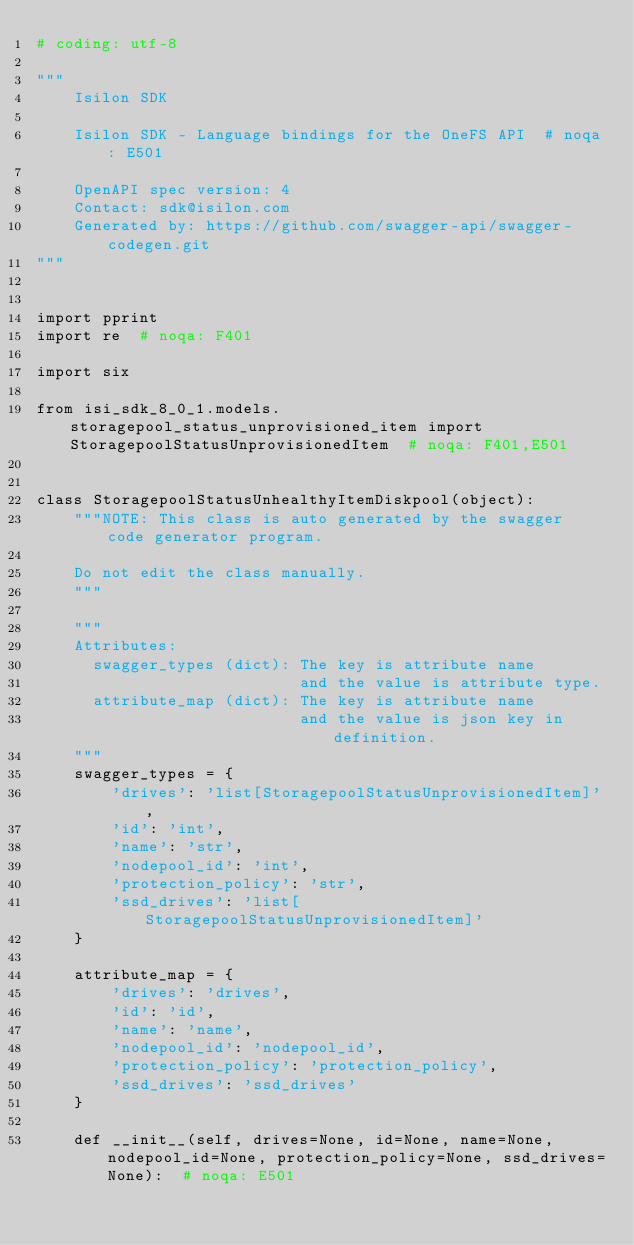Convert code to text. <code><loc_0><loc_0><loc_500><loc_500><_Python_># coding: utf-8

"""
    Isilon SDK

    Isilon SDK - Language bindings for the OneFS API  # noqa: E501

    OpenAPI spec version: 4
    Contact: sdk@isilon.com
    Generated by: https://github.com/swagger-api/swagger-codegen.git
"""


import pprint
import re  # noqa: F401

import six

from isi_sdk_8_0_1.models.storagepool_status_unprovisioned_item import StoragepoolStatusUnprovisionedItem  # noqa: F401,E501


class StoragepoolStatusUnhealthyItemDiskpool(object):
    """NOTE: This class is auto generated by the swagger code generator program.

    Do not edit the class manually.
    """

    """
    Attributes:
      swagger_types (dict): The key is attribute name
                            and the value is attribute type.
      attribute_map (dict): The key is attribute name
                            and the value is json key in definition.
    """
    swagger_types = {
        'drives': 'list[StoragepoolStatusUnprovisionedItem]',
        'id': 'int',
        'name': 'str',
        'nodepool_id': 'int',
        'protection_policy': 'str',
        'ssd_drives': 'list[StoragepoolStatusUnprovisionedItem]'
    }

    attribute_map = {
        'drives': 'drives',
        'id': 'id',
        'name': 'name',
        'nodepool_id': 'nodepool_id',
        'protection_policy': 'protection_policy',
        'ssd_drives': 'ssd_drives'
    }

    def __init__(self, drives=None, id=None, name=None, nodepool_id=None, protection_policy=None, ssd_drives=None):  # noqa: E501</code> 